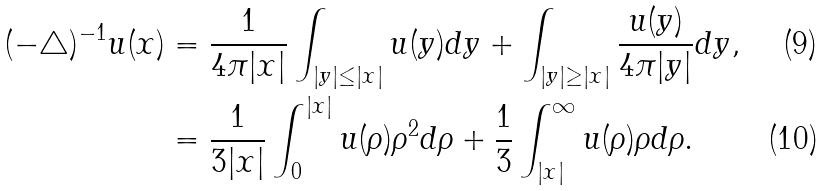<formula> <loc_0><loc_0><loc_500><loc_500>( - \triangle ) ^ { - 1 } u ( x ) & = \frac { 1 } { 4 \pi | x | } \int _ { | y | \leq | x | } u ( y ) d y + \int _ { | y | \geq | x | } \frac { u ( y ) } { 4 \pi | y | } d y , \\ & = \frac { 1 } { 3 | x | } \int _ { 0 } ^ { | x | } u ( \rho ) \rho ^ { 2 } d \rho + \frac { 1 } { 3 } \int _ { | x | } ^ { \infty } u ( \rho ) \rho d \rho .</formula> 